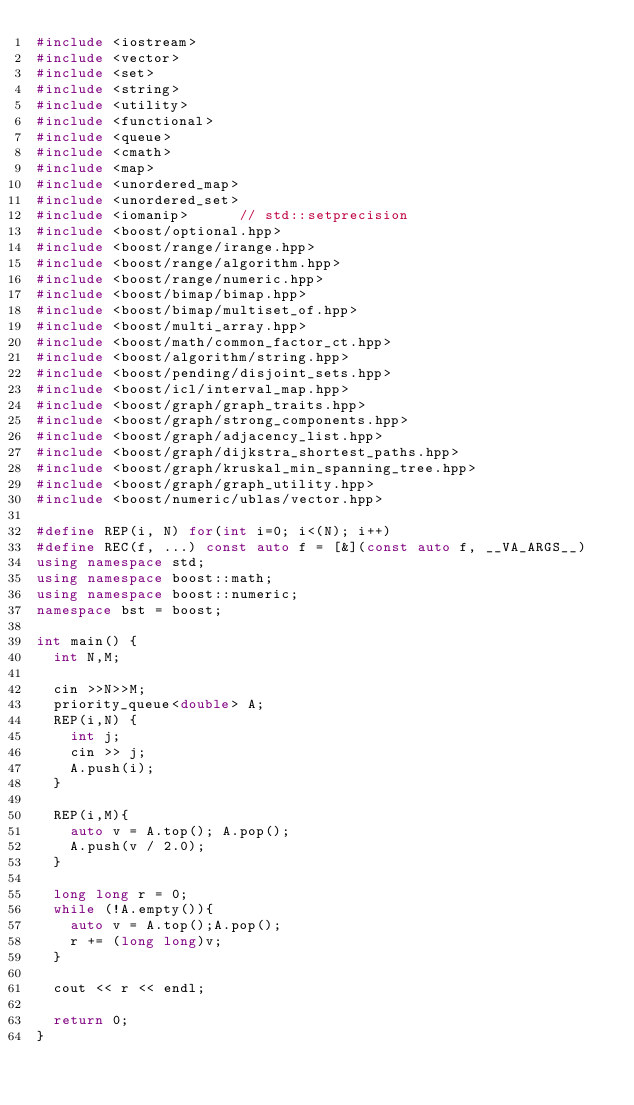<code> <loc_0><loc_0><loc_500><loc_500><_C++_>#include <iostream>
#include <vector>
#include <set>
#include <string>
#include <utility>
#include <functional>
#include <queue>
#include <cmath>
#include <map>
#include <unordered_map>
#include <unordered_set>
#include <iomanip>      // std::setprecision
#include <boost/optional.hpp>
#include <boost/range/irange.hpp>
#include <boost/range/algorithm.hpp>
#include <boost/range/numeric.hpp>
#include <boost/bimap/bimap.hpp>
#include <boost/bimap/multiset_of.hpp>
#include <boost/multi_array.hpp>
#include <boost/math/common_factor_ct.hpp>
#include <boost/algorithm/string.hpp>
#include <boost/pending/disjoint_sets.hpp>
#include <boost/icl/interval_map.hpp>
#include <boost/graph/graph_traits.hpp>
#include <boost/graph/strong_components.hpp>
#include <boost/graph/adjacency_list.hpp>
#include <boost/graph/dijkstra_shortest_paths.hpp>
#include <boost/graph/kruskal_min_spanning_tree.hpp>
#include <boost/graph/graph_utility.hpp>
#include <boost/numeric/ublas/vector.hpp>

#define REP(i, N) for(int i=0; i<(N); i++)
#define REC(f, ...) const auto f = [&](const auto f, __VA_ARGS__)
using namespace std;
using namespace boost::math;
using namespace boost::numeric;
namespace bst = boost;

int main() {
  int N,M;

  cin >>N>>M;
  priority_queue<double> A;
  REP(i,N) {
    int j;
    cin >> j;
    A.push(i);
  }
  
  REP(i,M){
    auto v = A.top(); A.pop();
    A.push(v / 2.0);
  }
  
  long long r = 0;
  while (!A.empty()){
    auto v = A.top();A.pop();
    r += (long long)v;
  }

  cout << r << endl;

  return 0;
}
</code> 